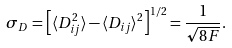Convert formula to latex. <formula><loc_0><loc_0><loc_500><loc_500>\sigma _ { D } = \left [ \langle D _ { i j } ^ { 2 } \rangle - \langle D _ { i j } \rangle ^ { 2 } \right ] ^ { 1 / 2 } = \frac { 1 } { \sqrt { 8 F } } .</formula> 